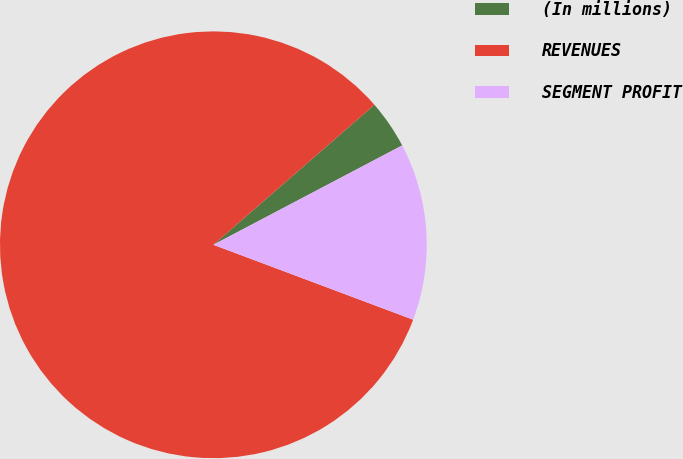<chart> <loc_0><loc_0><loc_500><loc_500><pie_chart><fcel>(In millions)<fcel>REVENUES<fcel>SEGMENT PROFIT<nl><fcel>3.68%<fcel>82.9%<fcel>13.42%<nl></chart> 